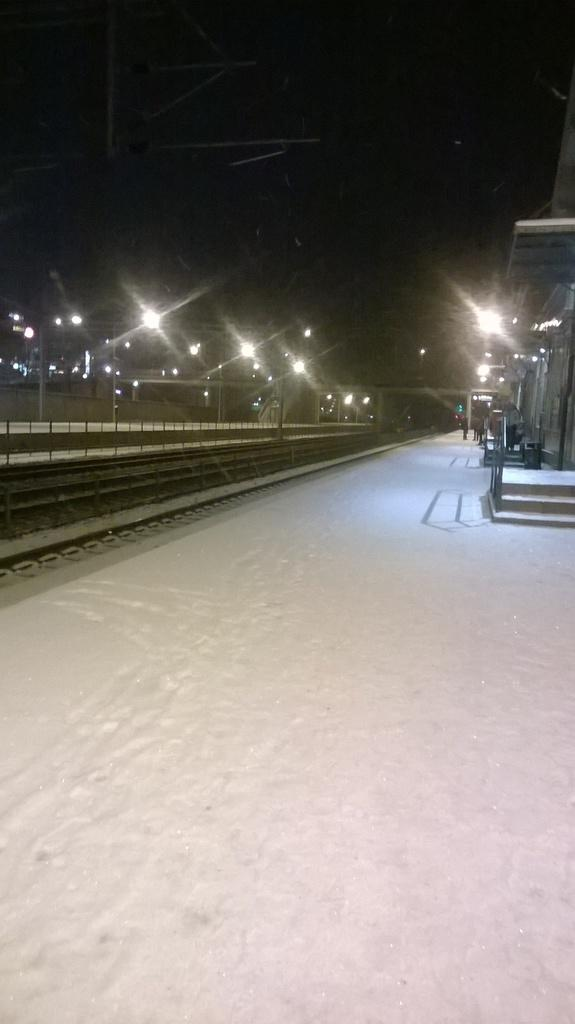What type of transportation infrastructure is visible in the image? There is a railway track in the image. What else can be seen in the image besides the railway track? There are many lights and a building visible in the image. Is there any pedestrian infrastructure in the image? Yes, there is a footpath in the image. How many apples are hanging from the railway track in the image? There are no apples present in the image, as it features a railway track, lights, a building, and a footpath. 